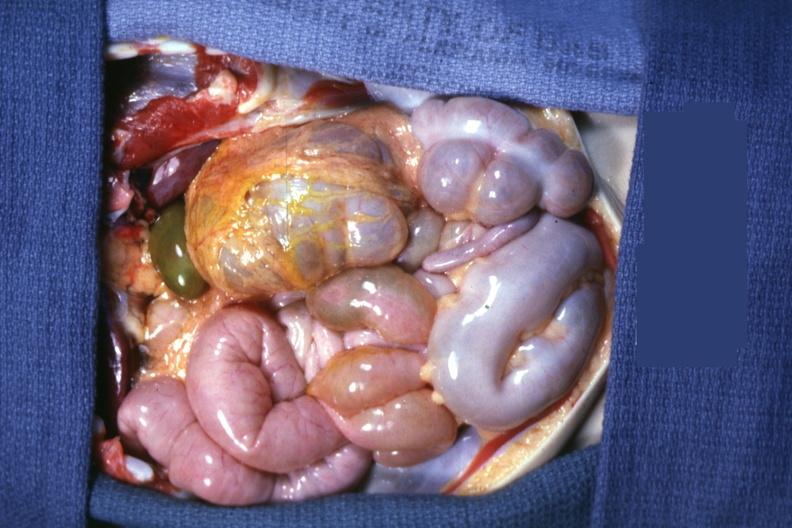where is this area in the body?
Answer the question using a single word or phrase. Abdomen 